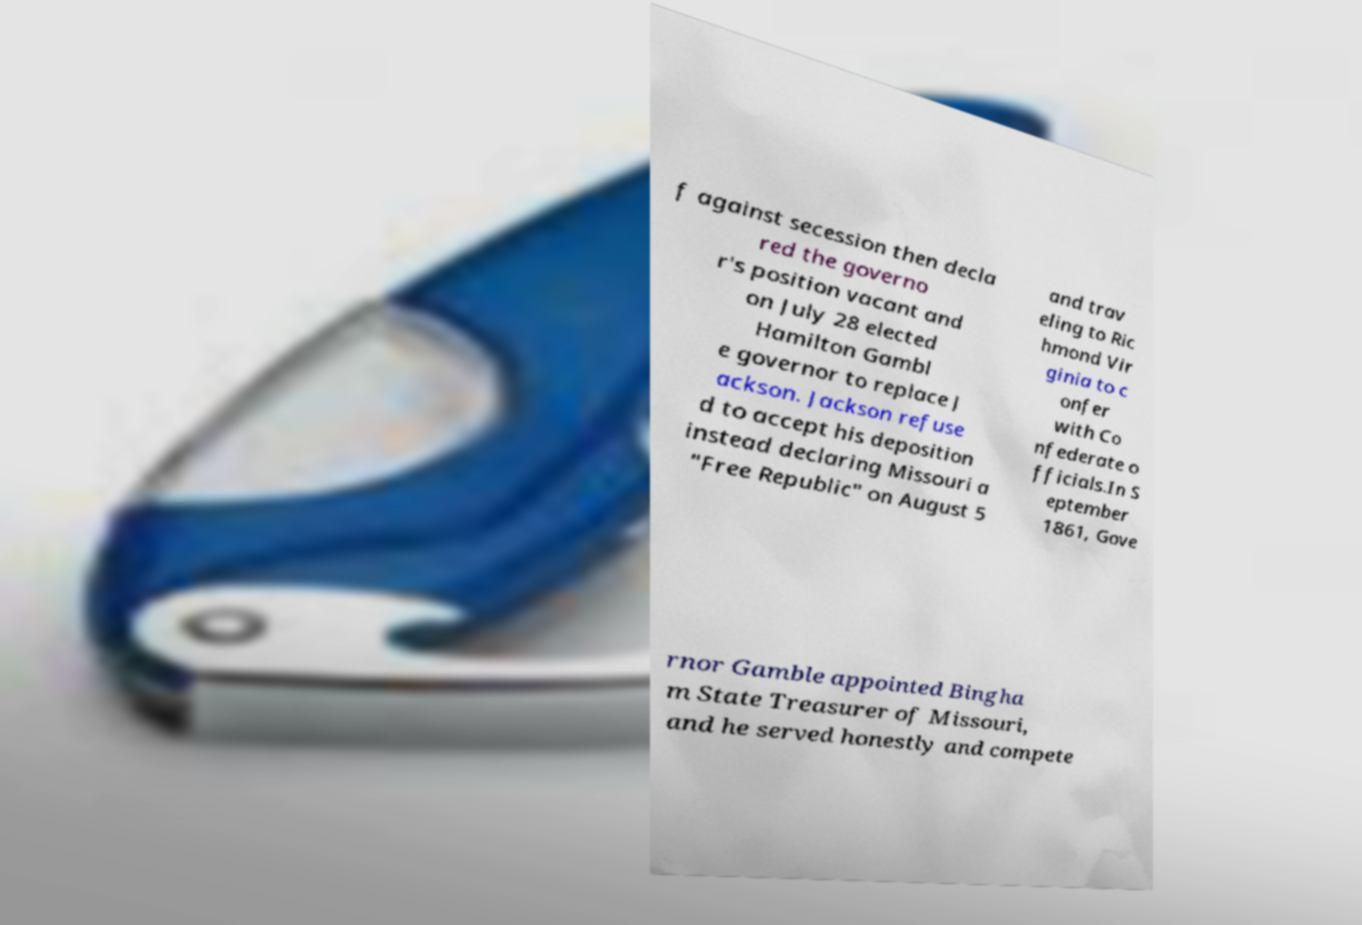Please read and relay the text visible in this image. What does it say? f against secession then decla red the governo r's position vacant and on July 28 elected Hamilton Gambl e governor to replace J ackson. Jackson refuse d to accept his deposition instead declaring Missouri a "Free Republic" on August 5 and trav eling to Ric hmond Vir ginia to c onfer with Co nfederate o fficials.In S eptember 1861, Gove rnor Gamble appointed Bingha m State Treasurer of Missouri, and he served honestly and compete 